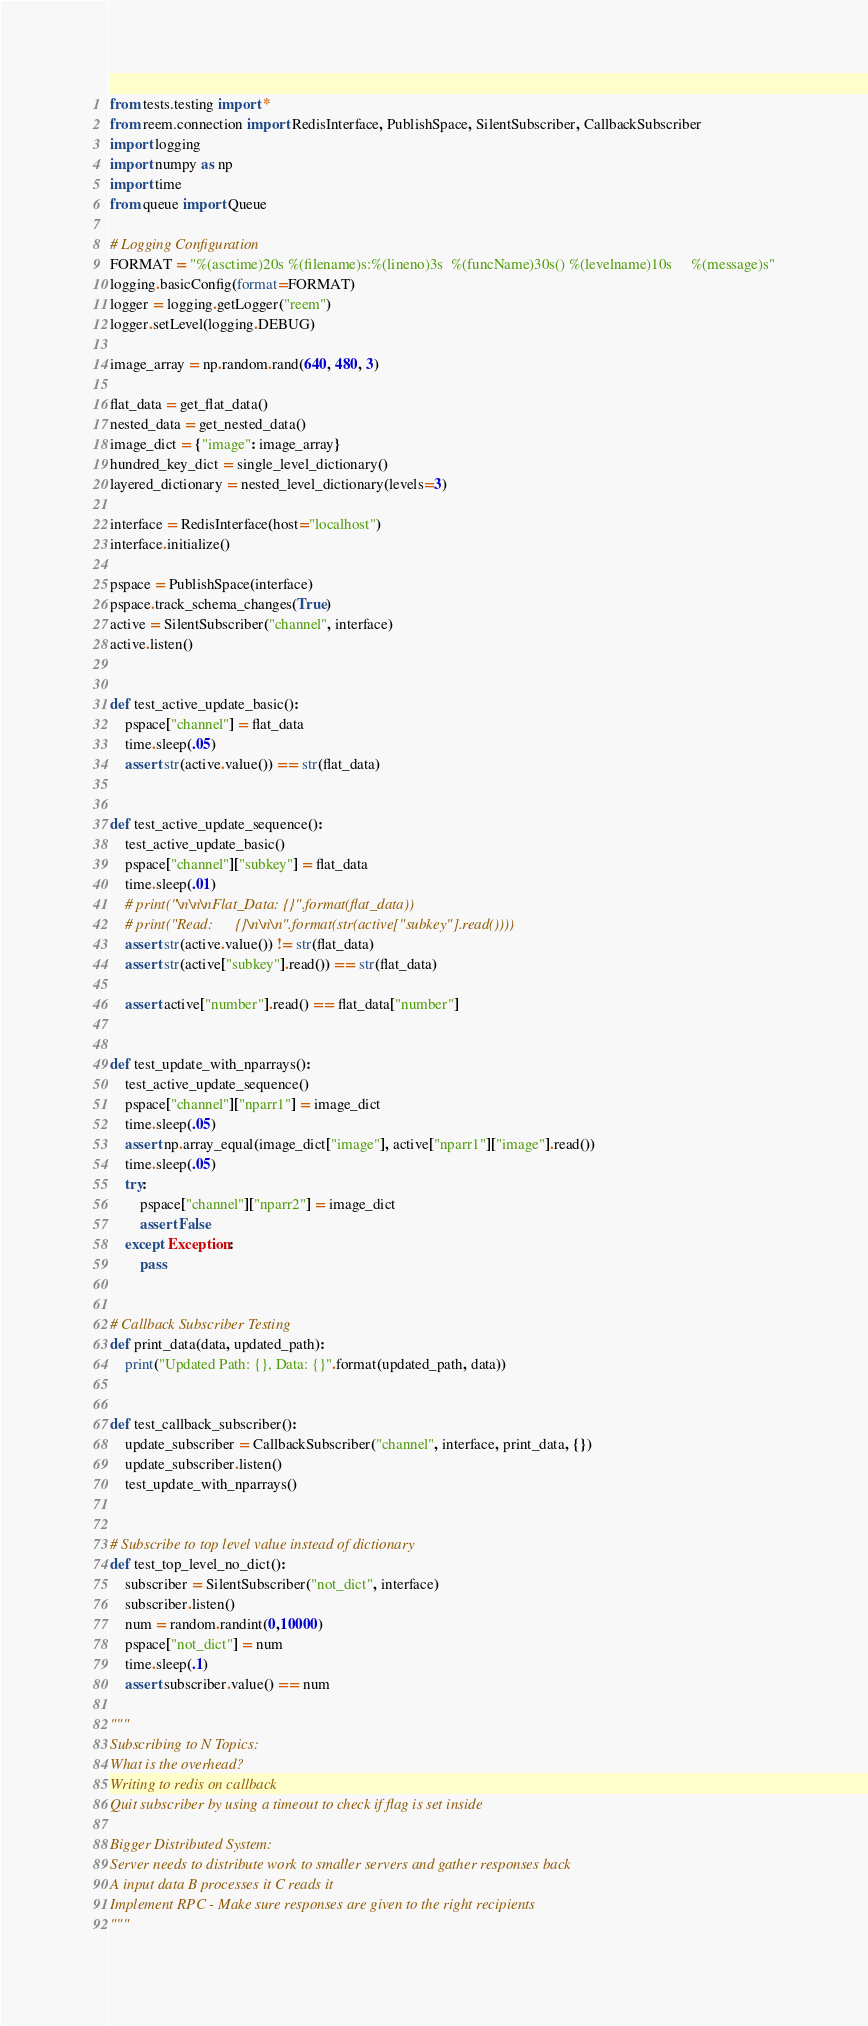<code> <loc_0><loc_0><loc_500><loc_500><_Python_>from tests.testing import *
from reem.connection import RedisInterface, PublishSpace, SilentSubscriber, CallbackSubscriber
import logging
import numpy as np
import time
from queue import Queue

# Logging Configuration
FORMAT = "%(asctime)20s %(filename)s:%(lineno)3s  %(funcName)30s() %(levelname)10s     %(message)s"
logging.basicConfig(format=FORMAT)
logger = logging.getLogger("reem")
logger.setLevel(logging.DEBUG)

image_array = np.random.rand(640, 480, 3)

flat_data = get_flat_data()
nested_data = get_nested_data()
image_dict = {"image": image_array}
hundred_key_dict = single_level_dictionary()
layered_dictionary = nested_level_dictionary(levels=3)

interface = RedisInterface(host="localhost")
interface.initialize()

pspace = PublishSpace(interface)
pspace.track_schema_changes(True)
active = SilentSubscriber("channel", interface)
active.listen()


def test_active_update_basic():
    pspace["channel"] = flat_data
    time.sleep(.05)
    assert str(active.value()) == str(flat_data)


def test_active_update_sequence():
    test_active_update_basic()
    pspace["channel"]["subkey"] = flat_data
    time.sleep(.01)
    # print("\n\n\nFlat_Data: {}".format(flat_data))
    # print("Read:      {}\n\n\n".format(str(active["subkey"].read())))
    assert str(active.value()) != str(flat_data)
    assert str(active["subkey"].read()) == str(flat_data)

    assert active["number"].read() == flat_data["number"]


def test_update_with_nparrays():
    test_active_update_sequence()
    pspace["channel"]["nparr1"] = image_dict
    time.sleep(.05)
    assert np.array_equal(image_dict["image"], active["nparr1"]["image"].read())
    time.sleep(.05)
    try:
        pspace["channel"]["nparr2"] = image_dict
        assert False
    except Exception:
        pass


# Callback Subscriber Testing
def print_data(data, updated_path):
    print("Updated Path: {}, Data: {}".format(updated_path, data))


def test_callback_subscriber():
    update_subscriber = CallbackSubscriber("channel", interface, print_data, {})
    update_subscriber.listen()
    test_update_with_nparrays()


# Subscribe to top level value instead of dictionary
def test_top_level_no_dict():
    subscriber = SilentSubscriber("not_dict", interface)
    subscriber.listen()
    num = random.randint(0,10000)
    pspace["not_dict"] = num
    time.sleep(.1)
    assert subscriber.value() == num

"""
Subscribing to N Topics:
What is the overhead?
Writing to redis on callback
Quit subscriber by using a timeout to check if flag is set inside

Bigger Distributed System:
Server needs to distribute work to smaller servers and gather responses back
A input data B processes it C reads it
Implement RPC - Make sure responses are given to the right recipients
"""





</code> 